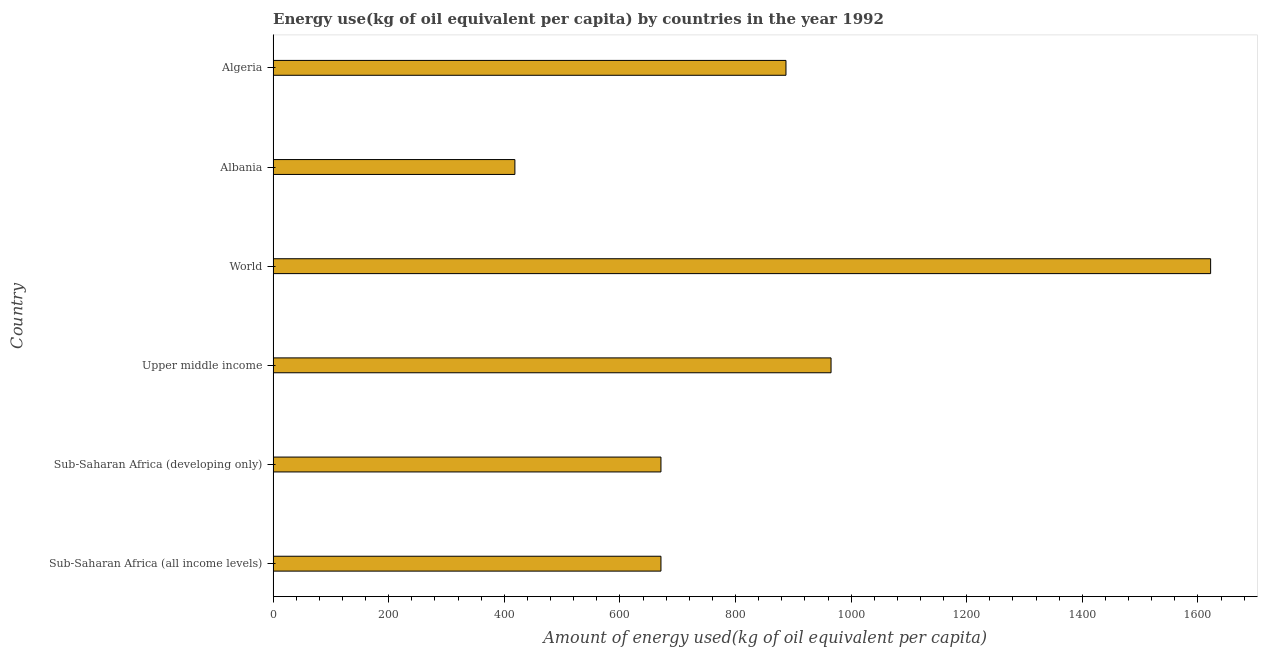What is the title of the graph?
Offer a very short reply. Energy use(kg of oil equivalent per capita) by countries in the year 1992. What is the label or title of the X-axis?
Your answer should be very brief. Amount of energy used(kg of oil equivalent per capita). What is the label or title of the Y-axis?
Ensure brevity in your answer.  Country. What is the amount of energy used in Upper middle income?
Offer a very short reply. 965.29. Across all countries, what is the maximum amount of energy used?
Give a very brief answer. 1621.98. Across all countries, what is the minimum amount of energy used?
Your response must be concise. 418.29. In which country was the amount of energy used maximum?
Your answer should be compact. World. In which country was the amount of energy used minimum?
Offer a terse response. Albania. What is the sum of the amount of energy used?
Your response must be concise. 5234.83. What is the difference between the amount of energy used in Sub-Saharan Africa (all income levels) and Sub-Saharan Africa (developing only)?
Ensure brevity in your answer.  -0. What is the average amount of energy used per country?
Give a very brief answer. 872.47. What is the median amount of energy used?
Ensure brevity in your answer.  779.14. What is the ratio of the amount of energy used in Albania to that in Sub-Saharan Africa (developing only)?
Provide a short and direct response. 0.62. Is the amount of energy used in Sub-Saharan Africa (all income levels) less than that in Sub-Saharan Africa (developing only)?
Make the answer very short. Yes. Is the difference between the amount of energy used in Upper middle income and World greater than the difference between any two countries?
Offer a very short reply. No. What is the difference between the highest and the second highest amount of energy used?
Keep it short and to the point. 656.69. Is the sum of the amount of energy used in Albania and Sub-Saharan Africa (developing only) greater than the maximum amount of energy used across all countries?
Your answer should be compact. No. What is the difference between the highest and the lowest amount of energy used?
Provide a short and direct response. 1203.69. In how many countries, is the amount of energy used greater than the average amount of energy used taken over all countries?
Your response must be concise. 3. How many bars are there?
Give a very brief answer. 6. Are all the bars in the graph horizontal?
Provide a short and direct response. Yes. How many countries are there in the graph?
Ensure brevity in your answer.  6. What is the difference between two consecutive major ticks on the X-axis?
Your answer should be very brief. 200. Are the values on the major ticks of X-axis written in scientific E-notation?
Offer a very short reply. No. What is the Amount of energy used(kg of oil equivalent per capita) in Sub-Saharan Africa (all income levels)?
Your answer should be compact. 670.99. What is the Amount of energy used(kg of oil equivalent per capita) in Sub-Saharan Africa (developing only)?
Offer a very short reply. 670.99. What is the Amount of energy used(kg of oil equivalent per capita) in Upper middle income?
Provide a short and direct response. 965.29. What is the Amount of energy used(kg of oil equivalent per capita) in World?
Keep it short and to the point. 1621.98. What is the Amount of energy used(kg of oil equivalent per capita) in Albania?
Offer a very short reply. 418.29. What is the Amount of energy used(kg of oil equivalent per capita) of Algeria?
Your answer should be very brief. 887.28. What is the difference between the Amount of energy used(kg of oil equivalent per capita) in Sub-Saharan Africa (all income levels) and Sub-Saharan Africa (developing only)?
Give a very brief answer. -0. What is the difference between the Amount of energy used(kg of oil equivalent per capita) in Sub-Saharan Africa (all income levels) and Upper middle income?
Keep it short and to the point. -294.29. What is the difference between the Amount of energy used(kg of oil equivalent per capita) in Sub-Saharan Africa (all income levels) and World?
Your response must be concise. -950.98. What is the difference between the Amount of energy used(kg of oil equivalent per capita) in Sub-Saharan Africa (all income levels) and Albania?
Offer a very short reply. 252.71. What is the difference between the Amount of energy used(kg of oil equivalent per capita) in Sub-Saharan Africa (all income levels) and Algeria?
Provide a succinct answer. -216.29. What is the difference between the Amount of energy used(kg of oil equivalent per capita) in Sub-Saharan Africa (developing only) and Upper middle income?
Keep it short and to the point. -294.29. What is the difference between the Amount of energy used(kg of oil equivalent per capita) in Sub-Saharan Africa (developing only) and World?
Provide a short and direct response. -950.98. What is the difference between the Amount of energy used(kg of oil equivalent per capita) in Sub-Saharan Africa (developing only) and Albania?
Your response must be concise. 252.71. What is the difference between the Amount of energy used(kg of oil equivalent per capita) in Sub-Saharan Africa (developing only) and Algeria?
Provide a short and direct response. -216.29. What is the difference between the Amount of energy used(kg of oil equivalent per capita) in Upper middle income and World?
Offer a very short reply. -656.69. What is the difference between the Amount of energy used(kg of oil equivalent per capita) in Upper middle income and Albania?
Provide a succinct answer. 547. What is the difference between the Amount of energy used(kg of oil equivalent per capita) in Upper middle income and Algeria?
Offer a very short reply. 78. What is the difference between the Amount of energy used(kg of oil equivalent per capita) in World and Albania?
Your answer should be compact. 1203.69. What is the difference between the Amount of energy used(kg of oil equivalent per capita) in World and Algeria?
Your answer should be very brief. 734.69. What is the difference between the Amount of energy used(kg of oil equivalent per capita) in Albania and Algeria?
Give a very brief answer. -469. What is the ratio of the Amount of energy used(kg of oil equivalent per capita) in Sub-Saharan Africa (all income levels) to that in Sub-Saharan Africa (developing only)?
Provide a succinct answer. 1. What is the ratio of the Amount of energy used(kg of oil equivalent per capita) in Sub-Saharan Africa (all income levels) to that in Upper middle income?
Provide a succinct answer. 0.69. What is the ratio of the Amount of energy used(kg of oil equivalent per capita) in Sub-Saharan Africa (all income levels) to that in World?
Keep it short and to the point. 0.41. What is the ratio of the Amount of energy used(kg of oil equivalent per capita) in Sub-Saharan Africa (all income levels) to that in Albania?
Your response must be concise. 1.6. What is the ratio of the Amount of energy used(kg of oil equivalent per capita) in Sub-Saharan Africa (all income levels) to that in Algeria?
Your answer should be compact. 0.76. What is the ratio of the Amount of energy used(kg of oil equivalent per capita) in Sub-Saharan Africa (developing only) to that in Upper middle income?
Keep it short and to the point. 0.69. What is the ratio of the Amount of energy used(kg of oil equivalent per capita) in Sub-Saharan Africa (developing only) to that in World?
Keep it short and to the point. 0.41. What is the ratio of the Amount of energy used(kg of oil equivalent per capita) in Sub-Saharan Africa (developing only) to that in Albania?
Offer a terse response. 1.6. What is the ratio of the Amount of energy used(kg of oil equivalent per capita) in Sub-Saharan Africa (developing only) to that in Algeria?
Your answer should be compact. 0.76. What is the ratio of the Amount of energy used(kg of oil equivalent per capita) in Upper middle income to that in World?
Make the answer very short. 0.59. What is the ratio of the Amount of energy used(kg of oil equivalent per capita) in Upper middle income to that in Albania?
Offer a terse response. 2.31. What is the ratio of the Amount of energy used(kg of oil equivalent per capita) in Upper middle income to that in Algeria?
Ensure brevity in your answer.  1.09. What is the ratio of the Amount of energy used(kg of oil equivalent per capita) in World to that in Albania?
Your response must be concise. 3.88. What is the ratio of the Amount of energy used(kg of oil equivalent per capita) in World to that in Algeria?
Provide a succinct answer. 1.83. What is the ratio of the Amount of energy used(kg of oil equivalent per capita) in Albania to that in Algeria?
Ensure brevity in your answer.  0.47. 